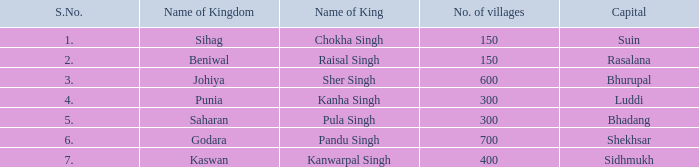Which kingdom has Suin as its capital? Sihag. 